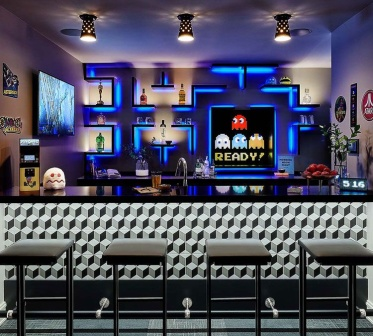Describe the following image. The image captures a lively scene at a modern bar themed after retro arcade gaming. At the forefront is a striking black and white checkered bar counter, which is complemented by four cushioned bar stools with sleek metal legs, inviting guests to take a seat. The floor matches the counter’s design, with its black and white pattern extending across the space. Against the right wall, a captivating array of neon lights depicts Pac-Man and four colorful ghosts — Inky, Blinky, Pinky, and Clyde — which playfully illuminate the space and set a nostalgic tone.

Behind the bar, the shelves are lit with a cool blue glow, showcasing a carefully arranged collection of bottles and decorative elements. On the bar’s surface, assorted glasses and a bowl filled with fresh fruits, such as apples and oranges, hint at the vibrant, refreshing cocktails ready to be crafted. Above these, a large screen displays 'PAC-MAN READY!', inviting patrons to relive the classic game.

The left wall features a small Pac-Man arcade cabinet, enhancing the retro theme, while various framed pictures and playful details spread throughout the room contribute to the bar's inviting ambiance. The overall meticulously designed space blends modern aesthetics with elements of playful nostalgia, creating a perfect setting for a night of fun and socializing. 